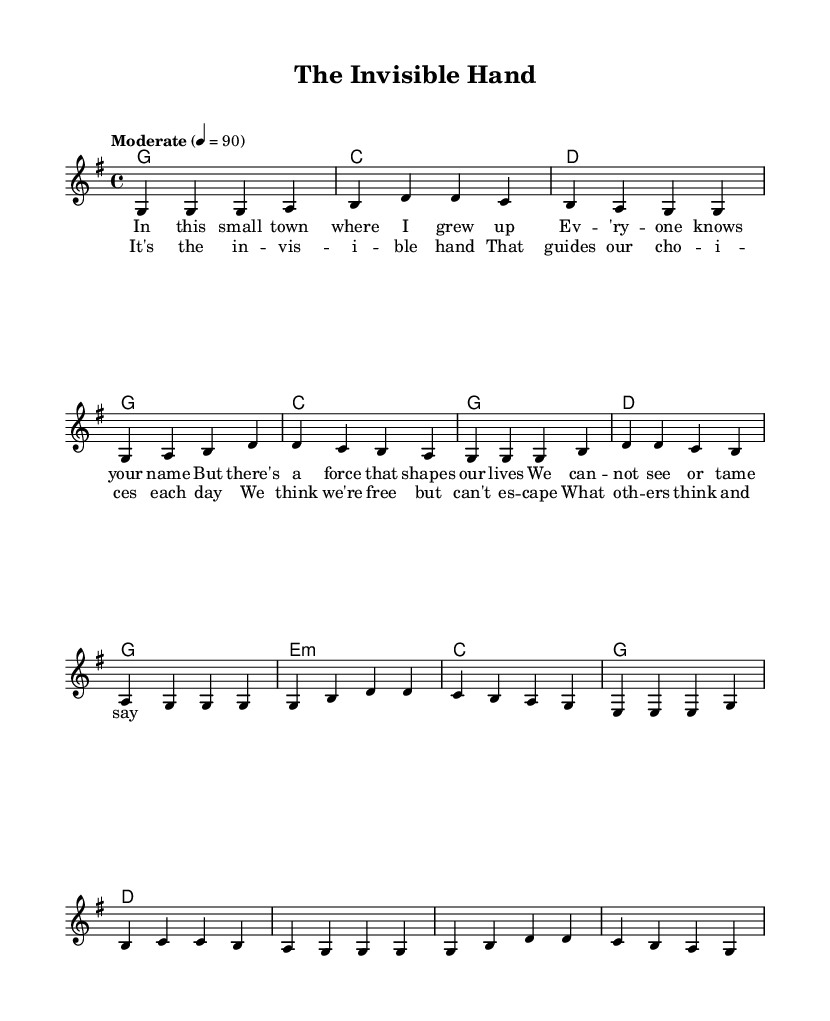What is the key signature of this music? The key signature is G major, which contains one sharp (F#). This can be identified by looking at the key signature symbol at the beginning of the staff which denotes the pitches included in the scale.
Answer: G major What is the time signature of this piece? The time signature is 4/4, indicated at the beginning of the score. This means there are 4 beats in each measure, and the quarter note gets one beat.
Answer: 4/4 What is the tempo marking for the music? The tempo marking indicates "Moderate" with a metronome mark of 90 beats per minute, showing the intended speed of the piece. This is provided near the top of the score.
Answer: Moderate 4 = 90 How many sections does the song have? The song has three sections: Verse, Chorus, and Bridge. This can be determined by examining the layout of the lyrics and the music, where they are distinctively marked.
Answer: Three What is the primary theme addressed in the lyrics? The primary theme addresses social influences on individual choices, as suggested by the lyrics referring to "the invisible hand" that shapes lives, highlighting the impact of societal perceptions.
Answer: Social influences What chords are used in the verse? The chords used in the verse are G, C, D, and G, as shown in the chord diagram under the verse section. This suggests a common progression in traditional country music emphasizing strong tonal centers.
Answer: G, C, D, G What is the melody's starting note? The melody starts on the note G, which is the first note of the first measure; this establishes the tonal foundation of the piece.
Answer: G 